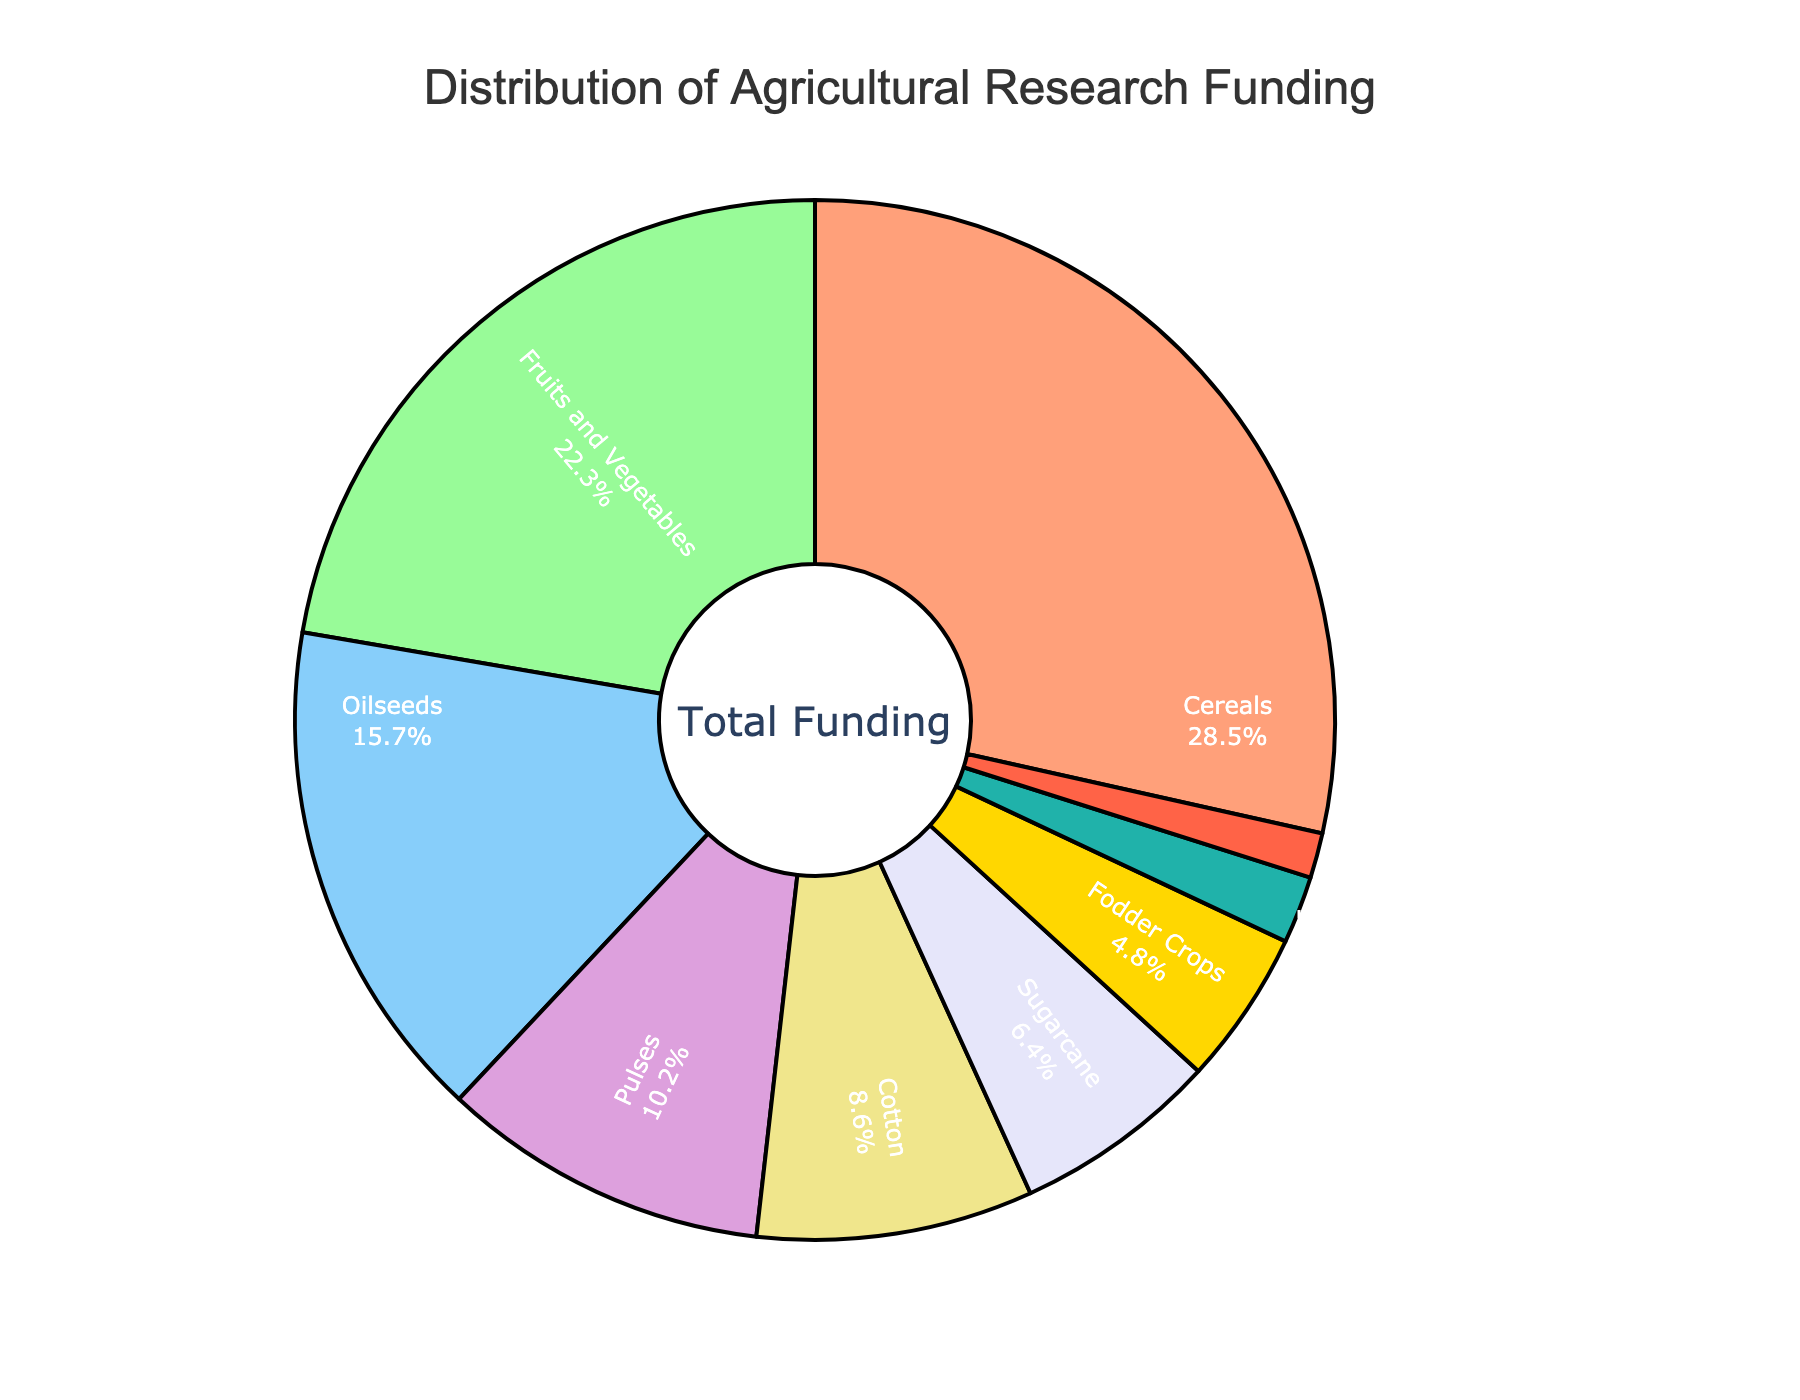Which crop category receives the highest percentage of research funding? The pie chart shows "Cereals" with the largest section of the chart and the highest percentage at 28.5%.
Answer: Cereals Which crop category is allocated the least research funding? The smallest section of the pie chart corresponds to "Specialty Crops" with the lowest percentage at 1.4%.
Answer: Specialty Crops Compare the research funding between Fruits and Vegetables and Oilseeds. Which one receives more funding and by how much? Fruits and Vegetables have a larger section on the pie chart at 22.3%, while Oilseeds have a smaller section at 15.7%. The difference in funding is 22.3% - 15.7% = 6.6%.
Answer: Fruits and Vegetables by 6.6% What is the combined research funding percentage for Cotton and Sugarcane? From the pie chart, Cotton receives 8.6% and Sugarcane 6.4%. Adding these gives 8.6% + 6.4% = 15%.
Answer: 15% How much more funding do Cereals receive compared to Pulses? The pie chart shows Cereals at 28.5% and Pulses at 10.2%. Subtracting these, we get 28.5% - 10.2% = 18.3%.
Answer: 18.3% What is the total percentage of funding allocated to Fodder Crops and Medicinal Plants together? The pie chart indicates that Fodder Crops receive 4.8% and Medicinal Plants 2.1%. Adding these gives 4.8% + 2.1% = 6.9%.
Answer: 6.9% Which category receives slightly less funding than Sugarcane? Sugarcane is allocated 6.4% of funding, and the next slightly lower percentage shown on the pie chart is Fodder Crops at 4.8%.
Answer: Fodder Crops What's the difference in funding percentage between the highest and lowest funded categories? The highest funded category is "Cereals" at 28.5%, and the lowest is "Specialty Crops" at 1.4%. The difference is 28.5% - 1.4% = 27.1%.
Answer: 27.1% What percentage of funding is allocated to categories other than Cereals, Fruits and Vegetables, and Oilseeds? Adding the percentages for Cereals (28.5%), Fruits and Vegetables (22.3%), and Oilseeds (15.7%) gives 28.5% + 22.3% + 15.7% = 66.5%. The total funding is 100%, so the remaining categories receive 100% - 66.5% = 33.5%.
Answer: 33.5% 